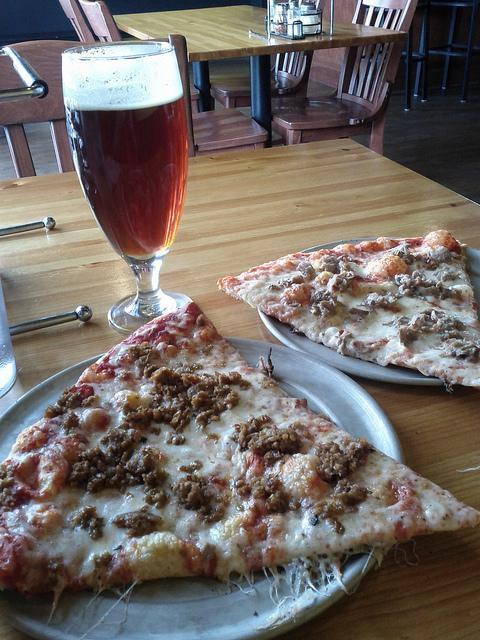How many plates are on the table?
Give a very brief answer. 2. How many pizzas are there?
Give a very brief answer. 2. How many chairs are in the photo?
Give a very brief answer. 4. How many chair legs are touching only the orange surface of the floor?
Give a very brief answer. 0. 